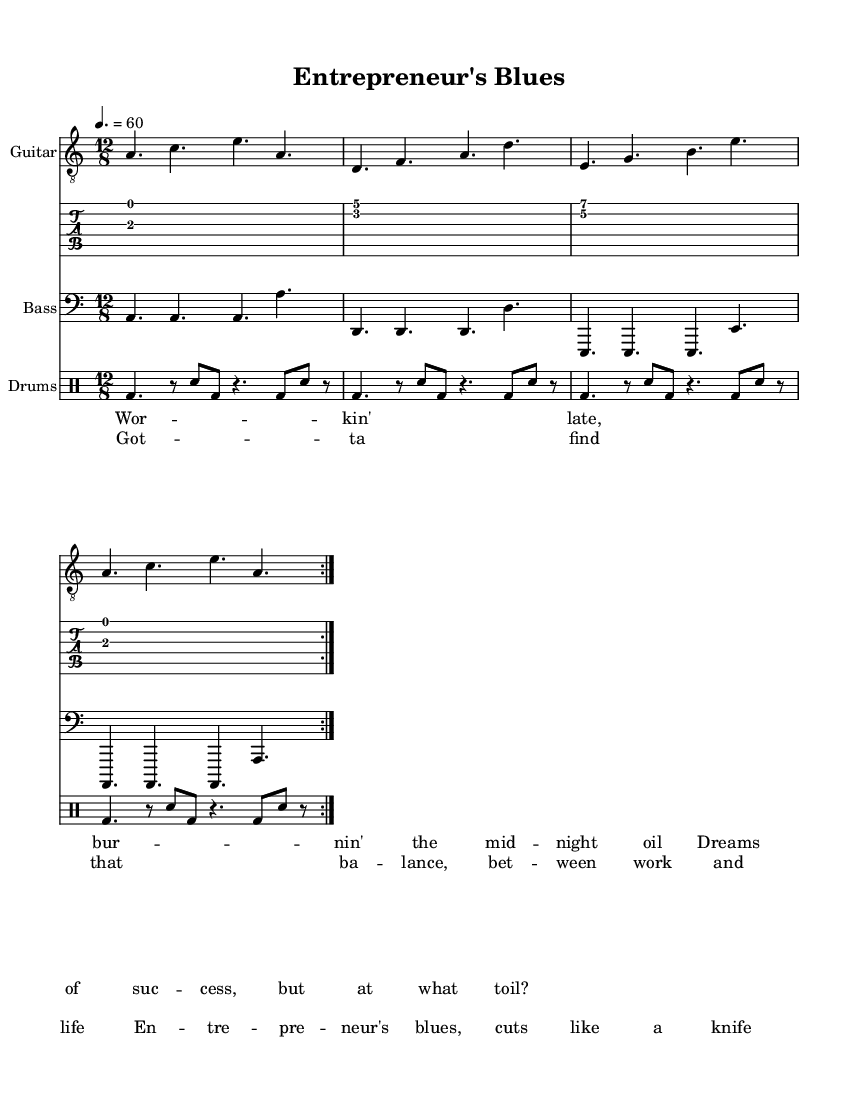What is the key signature of this music? The key signature is A minor, which contains no sharps or flats, indicated at the beginning of the staff.
Answer: A minor What is the time signature of this music? The time signature displayed at the beginning of the score is 12/8, which indicates a compound meter often used in blues and jazz music.
Answer: 12/8 What is the tempo marking for this piece? The tempo marking indicates a speed of 60 beats per minute, shown above the staff at the beginning of the score.
Answer: 60 How many times is the guitar section repeated? The guitar music section is marked with "volta 2", indicating that the section should be repeated two times.
Answer: 2 What lyrical theme is expressed in the verse? The verse lyrics describe a struggle with working late and the pursuit of success, reflecting the common battle between work and personal life faced by entrepreneurs.
Answer: Working late What is the primary focus of the chorus lyrics? The chorus lyrics emphasize the need to find a balance between work and life, which is a central theme in the exploration of entrepreneurship.
Answer: Balance What is the musical genre of this piece? The overall context of the music, reflected in the style and the title, suggests it falls within the genre of Electric Blues, characterized by its soulful and expressive nature.
Answer: Electric Blues 